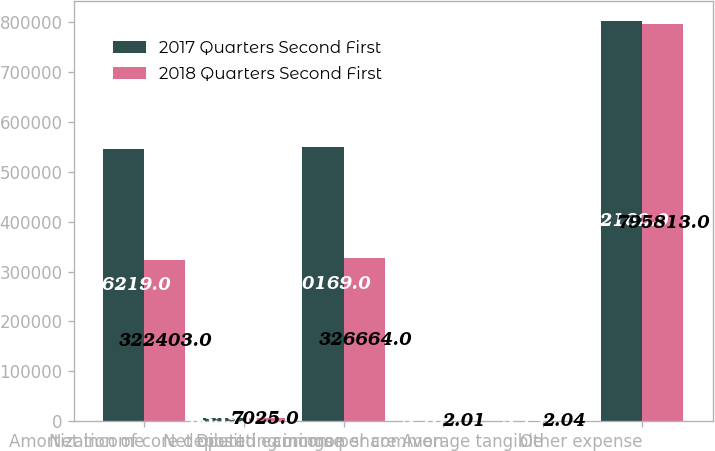Convert chart to OTSL. <chart><loc_0><loc_0><loc_500><loc_500><stacked_bar_chart><ecel><fcel>Net income<fcel>Amortization of core deposit<fcel>Net operating income<fcel>Diluted earnings per common<fcel>common share Average tangible<fcel>Other expense<nl><fcel>2017 Quarters Second First<fcel>546219<fcel>5359<fcel>550169<fcel>3.76<fcel>3.79<fcel>802162<nl><fcel>2018 Quarters Second First<fcel>322403<fcel>7025<fcel>326664<fcel>2.01<fcel>2.04<fcel>795813<nl></chart> 